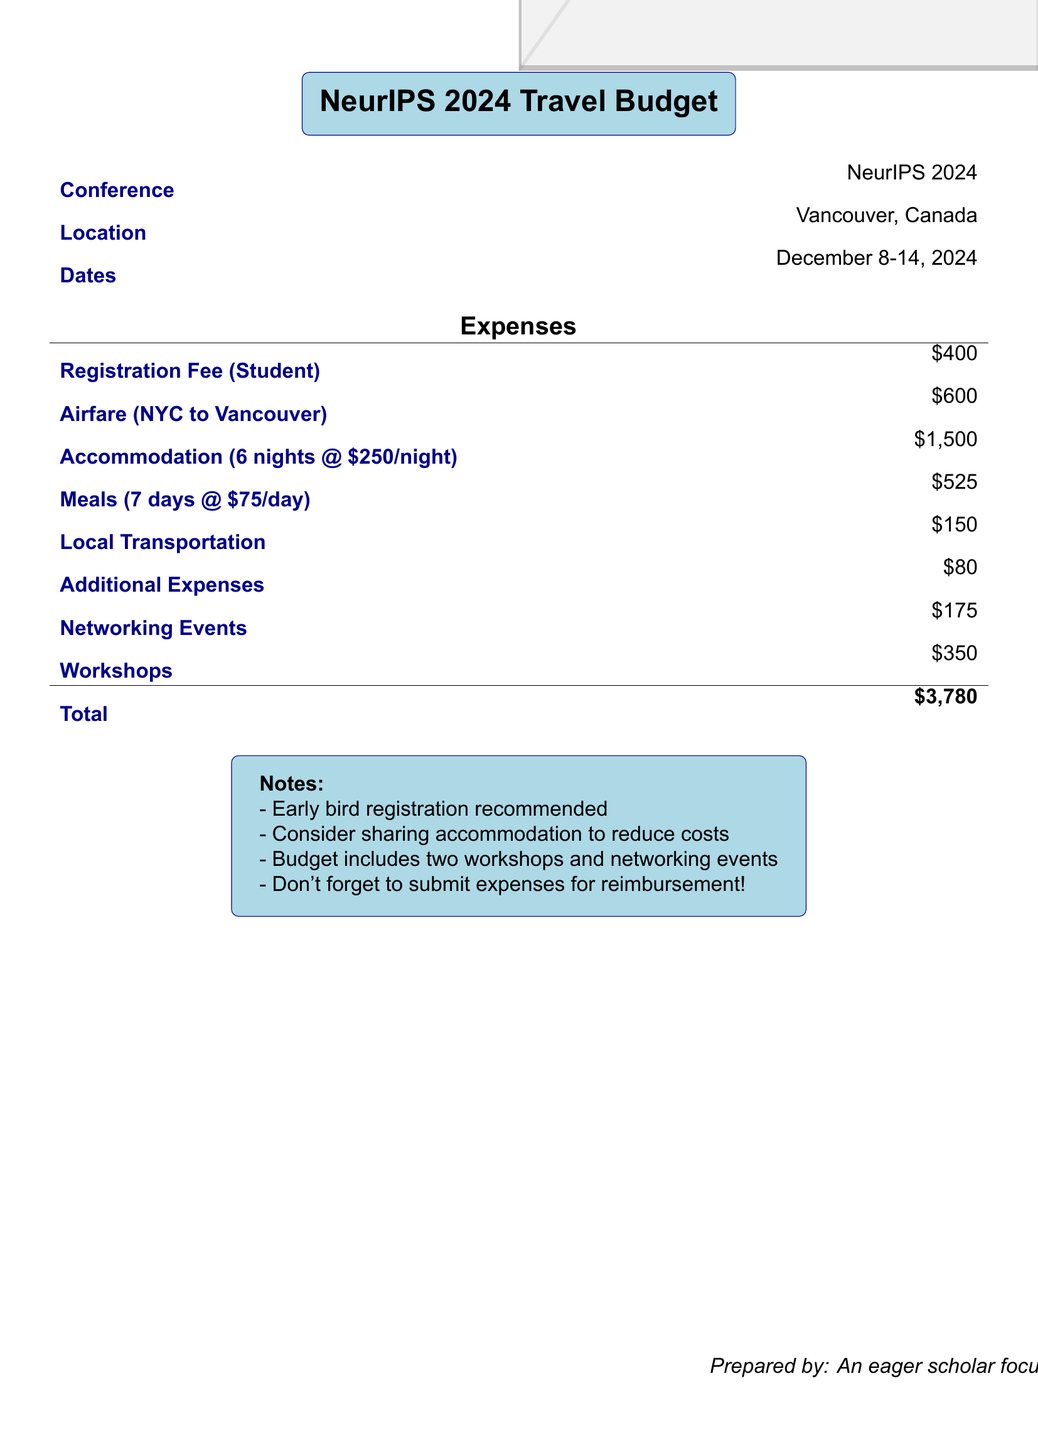What is the conference title? The conference title is specified at the beginning of the document, which is "NeurIPS 2024 Travel Budget."
Answer: NeurIPS 2024 Travel Budget Where is the conference located? The document states the location of the conference is "Vancouver, Canada."
Answer: Vancouver, Canada What is the registration fee for students? The registration fee is listed under expenses, specifically marked for students.
Answer: $400 How many nights of accommodation are budgeted? The document indicates the accommodation cost is calculated for "6 nights."
Answer: 6 nights What is the total estimated budget? The total budget is at the end of the expenses section, summing all costs listed.
Answer: $3,780 How much is allocated for meals? The meals expense is specified with a per-day rate multiplied by the number of days, which gives the total meals cost.
Answer: $525 What date does the conference start? The start date of the conference is provided in the dates section of the document.
Answer: December 8, 2024 What is the budget for airfare? The documentation includes a specific value for airfare related to travel from NYC to Vancouver.
Answer: $600 What additional expenses are included in the budget? The document lists various expenses, with one specifically labeled as "Additional Expenses."
Answer: $80 